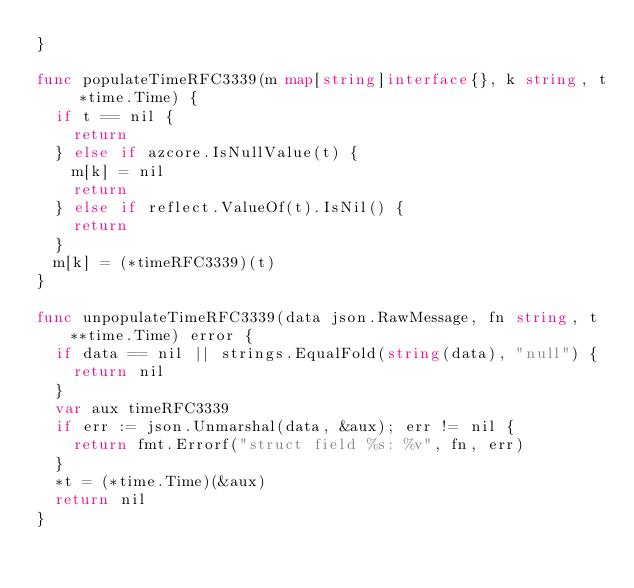<code> <loc_0><loc_0><loc_500><loc_500><_Go_>}

func populateTimeRFC3339(m map[string]interface{}, k string, t *time.Time) {
	if t == nil {
		return
	} else if azcore.IsNullValue(t) {
		m[k] = nil
		return
	} else if reflect.ValueOf(t).IsNil() {
		return
	}
	m[k] = (*timeRFC3339)(t)
}

func unpopulateTimeRFC3339(data json.RawMessage, fn string, t **time.Time) error {
	if data == nil || strings.EqualFold(string(data), "null") {
		return nil
	}
	var aux timeRFC3339
	if err := json.Unmarshal(data, &aux); err != nil {
		return fmt.Errorf("struct field %s: %v", fn, err)
	}
	*t = (*time.Time)(&aux)
	return nil
}
</code> 